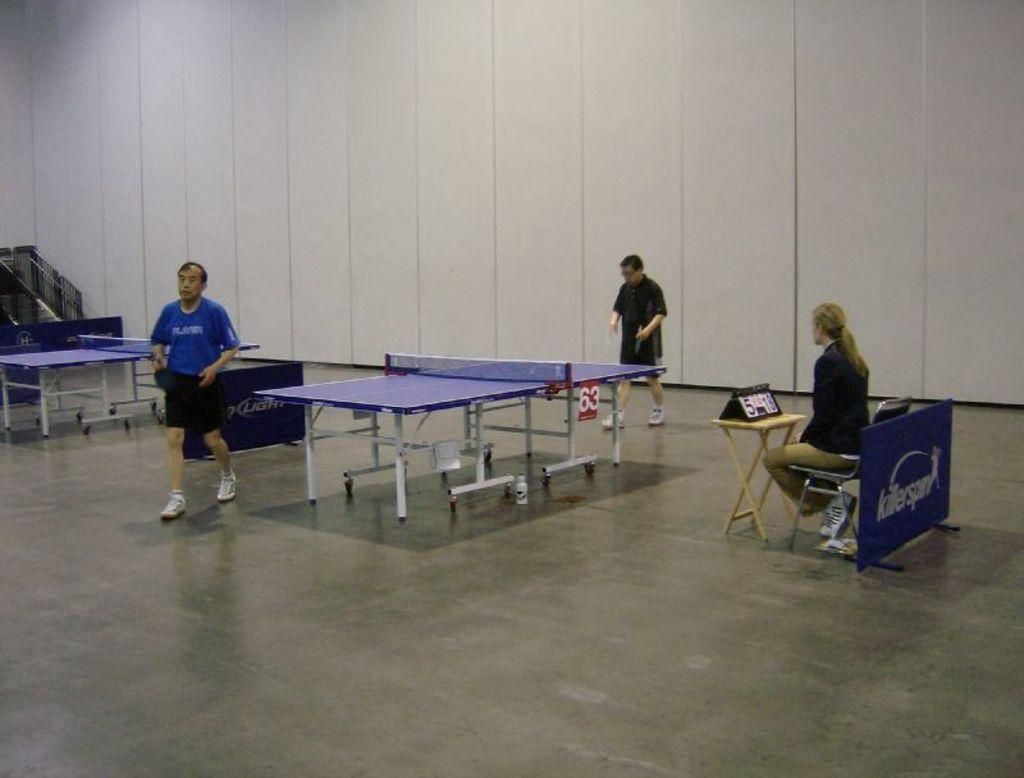What activity is being depicted in the image? People are standing near a table tennis board, suggesting they are playing or about to play table tennis. What is the woman doing in the image? The woman is sitting on a chair near a table. What can be seen in the background of the image? There is a wall in the background of the image. What type of crack can be seen on the bed in the image? There is no bed present in the image, so there cannot be any cracks on it. 